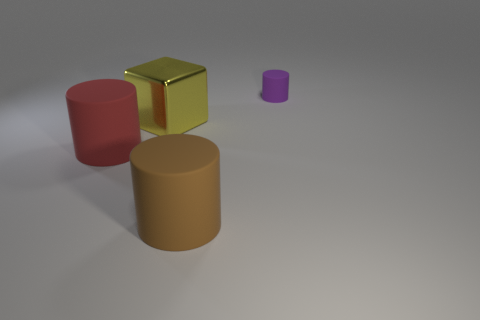How many things are big things right of the large red thing or things that are left of the large shiny thing?
Keep it short and to the point. 3. What color is the rubber cylinder that is both on the right side of the metal cube and in front of the large yellow shiny thing?
Your answer should be very brief. Brown. Are there more big metallic things than big green rubber cylinders?
Keep it short and to the point. Yes. Do the matte thing that is behind the big block and the yellow object have the same shape?
Keep it short and to the point. No. What number of matte things are either big brown cubes or brown cylinders?
Give a very brief answer. 1. Are there any small brown cylinders that have the same material as the large cube?
Provide a short and direct response. No. What is the block made of?
Keep it short and to the point. Metal. There is a thing that is on the right side of the large cylinder on the right side of the big rubber cylinder that is to the left of the brown cylinder; what shape is it?
Provide a short and direct response. Cylinder. Is the number of cylinders that are left of the tiny rubber object greater than the number of brown things?
Provide a succinct answer. Yes. Do the tiny purple matte thing and the large object to the left of the cube have the same shape?
Your answer should be compact. Yes. 